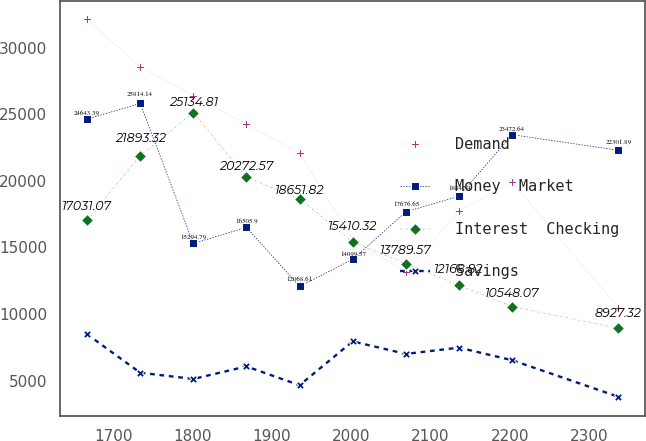Convert chart. <chart><loc_0><loc_0><loc_500><loc_500><line_chart><ecel><fcel>Demand<fcel>Money  Market<fcel>Interest  Checking<fcel>Savings<nl><fcel>1667.07<fcel>32126.1<fcel>24643.4<fcel>17031.1<fcel>8478.88<nl><fcel>1734.07<fcel>28577<fcel>25814.1<fcel>21893.3<fcel>5587.69<nl><fcel>1801.07<fcel>26412.4<fcel>15294.8<fcel>25134.8<fcel>5117.43<nl><fcel>1868.07<fcel>24247.8<fcel>16505.9<fcel>20272.6<fcel>6057.95<nl><fcel>1935.07<fcel>22083.2<fcel>12068.6<fcel>18651.8<fcel>4647.17<nl><fcel>2002.07<fcel>15589.3<fcel>14099.6<fcel>15410.3<fcel>7938.99<nl><fcel>2069.07<fcel>13158.5<fcel>17676.7<fcel>13789.6<fcel>6998.47<nl><fcel>2136.07<fcel>17754<fcel>18847.4<fcel>12168.8<fcel>7468.73<nl><fcel>2203.07<fcel>19918.6<fcel>23472.6<fcel>10548.1<fcel>6528.21<nl><fcel>2337.11<fcel>10480<fcel>22301.9<fcel>8927.32<fcel>3776.3<nl></chart> 